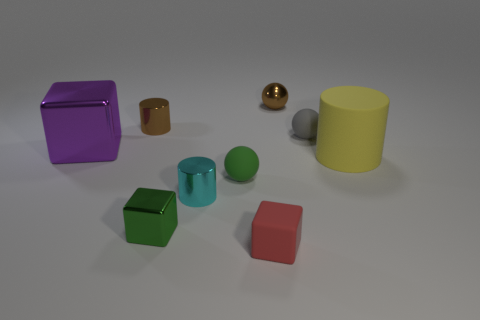There is a tiny brown metal thing left of the small red block; what is its shape?
Your answer should be compact. Cylinder. Are the ball to the left of the small brown sphere and the large thing that is right of the purple metal cube made of the same material?
Give a very brief answer. Yes. How many metallic things have the same shape as the yellow rubber thing?
Your answer should be compact. 2. There is a thing that is the same color as the shiny ball; what is it made of?
Ensure brevity in your answer.  Metal. How many objects are either large yellow matte cylinders or cylinders to the right of the metal ball?
Your answer should be compact. 1. What is the material of the red object?
Your answer should be very brief. Rubber. There is a large thing that is the same shape as the tiny red matte object; what is it made of?
Provide a short and direct response. Metal. What is the color of the tiny rubber ball that is left of the matte thing that is in front of the small green rubber object?
Offer a terse response. Green. What number of rubber objects are either small gray balls or yellow cylinders?
Keep it short and to the point. 2. Are the cyan cylinder and the brown cylinder made of the same material?
Your response must be concise. Yes. 